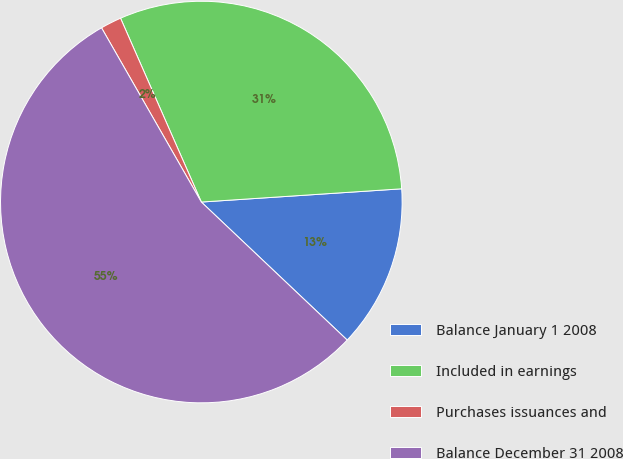<chart> <loc_0><loc_0><loc_500><loc_500><pie_chart><fcel>Balance January 1 2008<fcel>Included in earnings<fcel>Purchases issuances and<fcel>Balance December 31 2008<nl><fcel>13.11%<fcel>30.54%<fcel>1.69%<fcel>54.66%<nl></chart> 